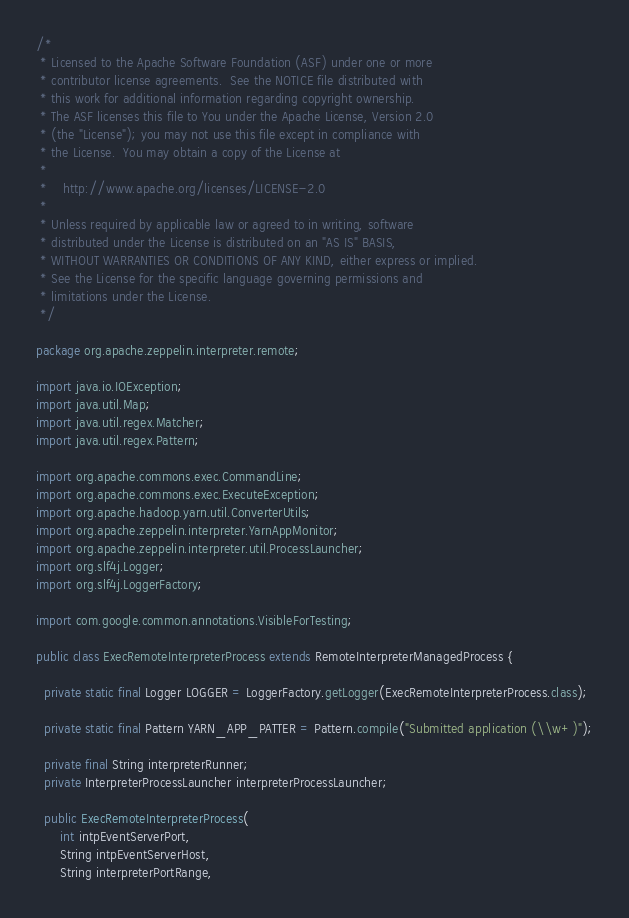Convert code to text. <code><loc_0><loc_0><loc_500><loc_500><_Java_>/*
 * Licensed to the Apache Software Foundation (ASF) under one or more
 * contributor license agreements.  See the NOTICE file distributed with
 * this work for additional information regarding copyright ownership.
 * The ASF licenses this file to You under the Apache License, Version 2.0
 * (the "License"); you may not use this file except in compliance with
 * the License.  You may obtain a copy of the License at
 *
 *    http://www.apache.org/licenses/LICENSE-2.0
 *
 * Unless required by applicable law or agreed to in writing, software
 * distributed under the License is distributed on an "AS IS" BASIS,
 * WITHOUT WARRANTIES OR CONDITIONS OF ANY KIND, either express or implied.
 * See the License for the specific language governing permissions and
 * limitations under the License.
 */

package org.apache.zeppelin.interpreter.remote;

import java.io.IOException;
import java.util.Map;
import java.util.regex.Matcher;
import java.util.regex.Pattern;

import org.apache.commons.exec.CommandLine;
import org.apache.commons.exec.ExecuteException;
import org.apache.hadoop.yarn.util.ConverterUtils;
import org.apache.zeppelin.interpreter.YarnAppMonitor;
import org.apache.zeppelin.interpreter.util.ProcessLauncher;
import org.slf4j.Logger;
import org.slf4j.LoggerFactory;

import com.google.common.annotations.VisibleForTesting;

public class ExecRemoteInterpreterProcess extends RemoteInterpreterManagedProcess {

  private static final Logger LOGGER = LoggerFactory.getLogger(ExecRemoteInterpreterProcess.class);

  private static final Pattern YARN_APP_PATTER = Pattern.compile("Submitted application (\\w+)");

  private final String interpreterRunner;
  private InterpreterProcessLauncher interpreterProcessLauncher;

  public ExecRemoteInterpreterProcess(
      int intpEventServerPort,
      String intpEventServerHost,
      String interpreterPortRange,</code> 